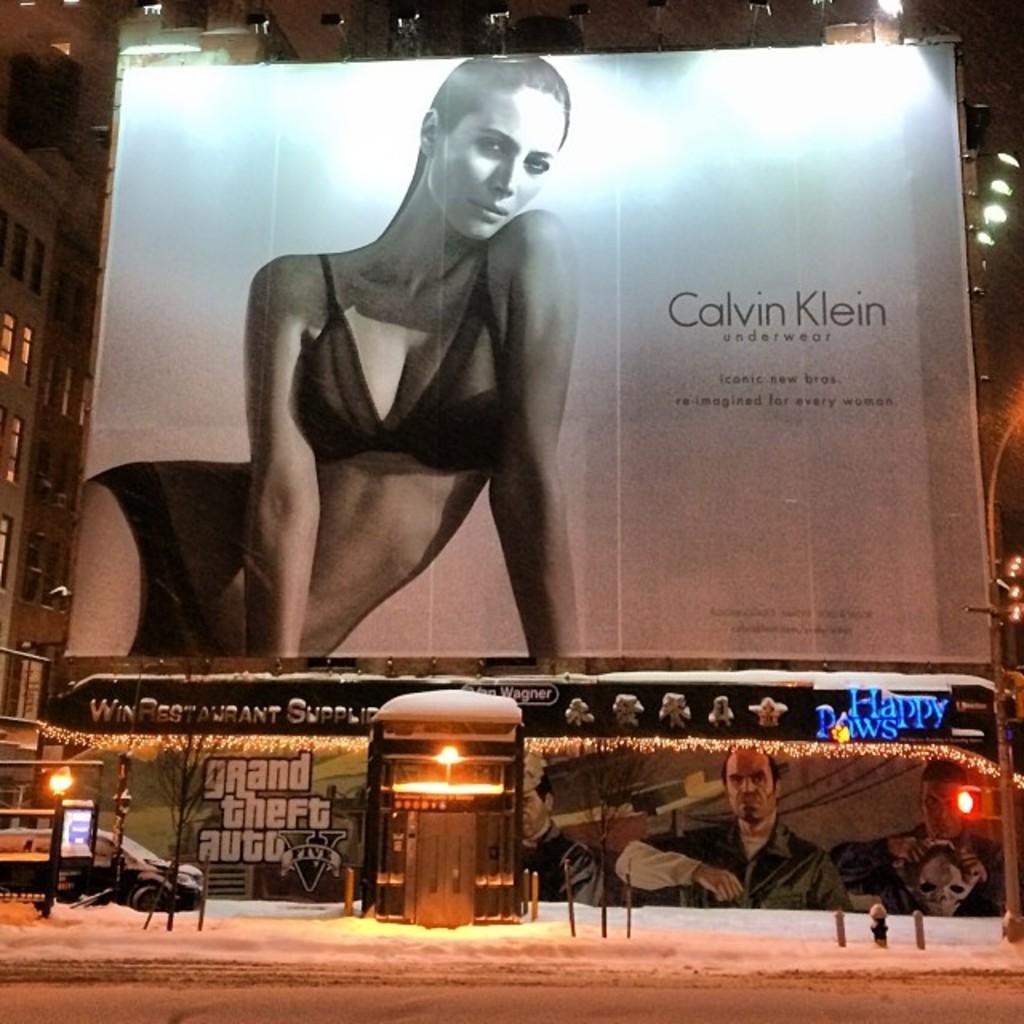What video game is advertised on the bottom left?
Your response must be concise. Grand theft auto. 